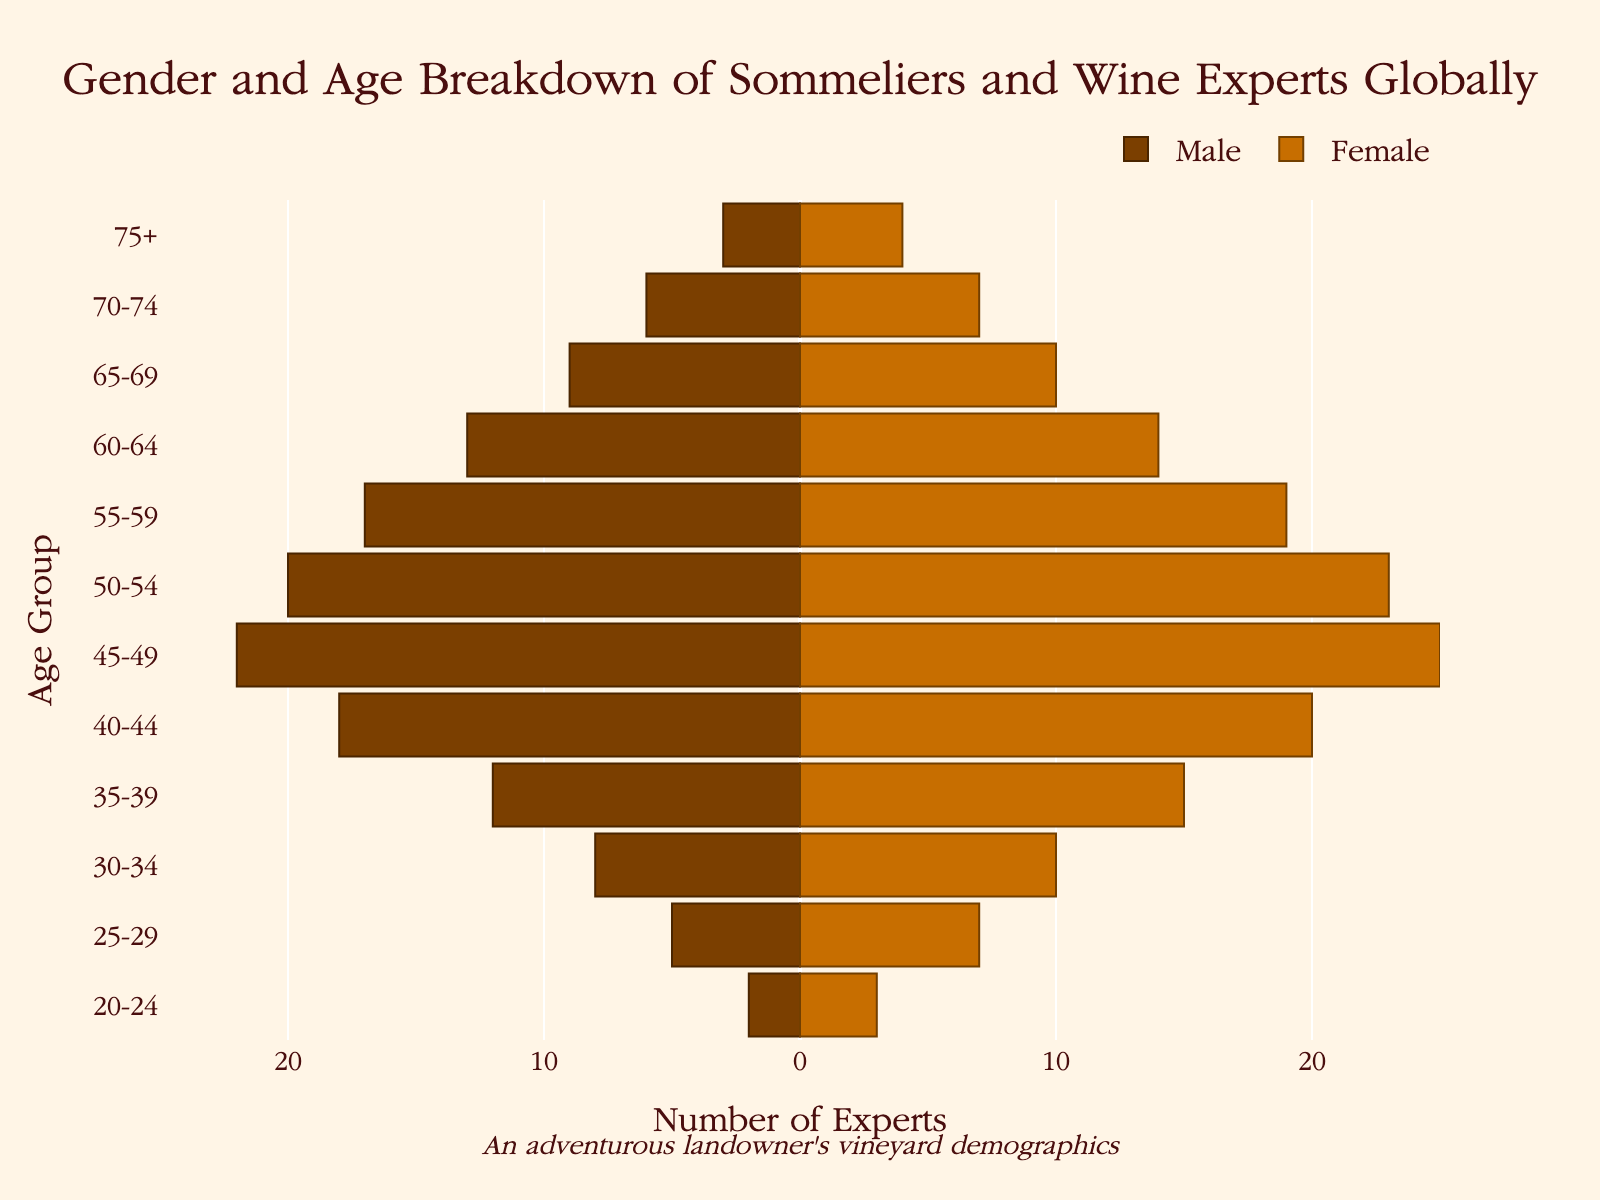What is the title of the figure? The title of the figure is found at the top center and provides a brief summary of the chart's content.
Answer: Gender and Age Breakdown of Sommeliers and Wine Experts Globally Which age group has the highest number of male sommeliers? By examining the longest bar on the negative side (left) of the x-axis, we can determine the age group with the highest number of male sommeliers.
Answer: 45-49 What is the total number of wine experts in the 50-54 age group? Add the number of male and female experts in the 50-54 age group: 20 (male) + 23 (female) = 43.
Answer: 43 How many more female sommeliers are there in the age group 35-39 compared to male sommeliers in the same group? Subtract the number of male sommeliers from the number of female sommeliers in the 35-39 age group: 15 (female) - 12 (male) = 3.
Answer: 3 Which age group has an equal number of male and female sommeliers? Check each age group to see where the bars for male and female are equal in length.
Answer: 75+ How do the numbers of male and female sommeliers in the 40-44 age group compare? Compare the lengths of the bars for males and females in the 40-44 age group: 18 (male) is less than 20 (female).
Answer: Male numbers are less than female numbers What is the total number of sommeliers aged 20-24? Add the number of male and female sommeliers in the 20-24 age group: 2 (male) + 3 (female) = 5.
Answer: 5 How does the number of female sommeliers in the 65-69 age group compare to those in the 60-64 age group? Compare the lengths of the female bars in the 65-69 and 60-64 age groups: 10 (65-69) is less than 14 (60-64).
Answer: Fewer in 65-69 Which gender has more sommeliers in the 55-59 age range? Compare the lengths of the bars for males and females in the 55-59 age group: 17 (male) is less than 19 (female).
Answer: Female What is the combined total number of sommeliers in the three oldest age groups (65-69, 70-74, 75+)? Add the number of male and female sommeliers in the three oldest age groups: (9 + 10) + (6 + 7) + (3 + 4) = 19 + 13 + 7 = 39.
Answer: 39 